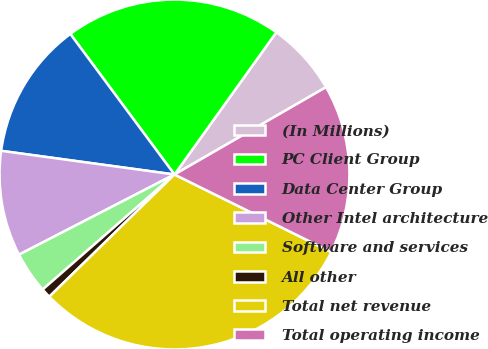Convert chart to OTSL. <chart><loc_0><loc_0><loc_500><loc_500><pie_chart><fcel>(In Millions)<fcel>PC Client Group<fcel>Data Center Group<fcel>Other Intel architecture<fcel>Software and services<fcel>All other<fcel>Total net revenue<fcel>Total operating income<nl><fcel>6.79%<fcel>20.04%<fcel>12.69%<fcel>9.74%<fcel>3.84%<fcel>0.89%<fcel>30.38%<fcel>15.63%<nl></chart> 